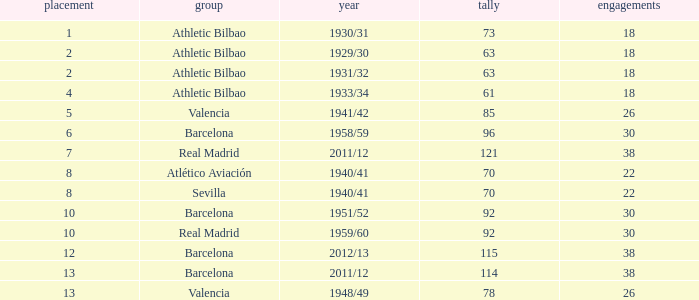What are the apps for less than 61 goals and before rank 6? None. 